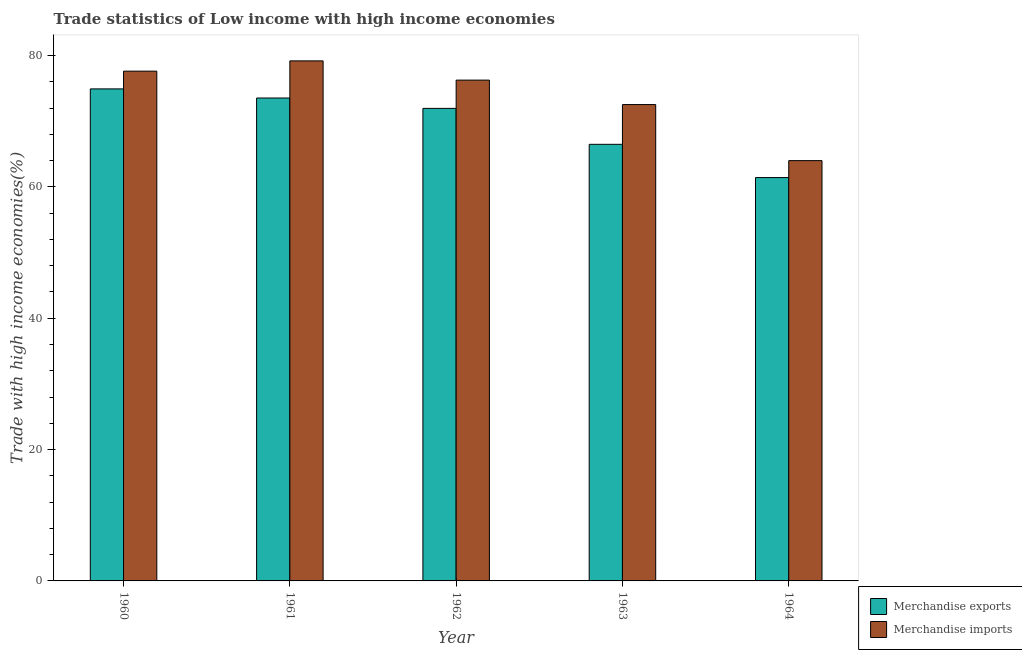How many different coloured bars are there?
Your answer should be very brief. 2. How many bars are there on the 1st tick from the left?
Keep it short and to the point. 2. How many bars are there on the 3rd tick from the right?
Make the answer very short. 2. What is the merchandise exports in 1963?
Offer a terse response. 66.48. Across all years, what is the maximum merchandise imports?
Your response must be concise. 79.18. Across all years, what is the minimum merchandise imports?
Provide a succinct answer. 63.99. In which year was the merchandise imports maximum?
Your answer should be compact. 1961. In which year was the merchandise exports minimum?
Provide a short and direct response. 1964. What is the total merchandise exports in the graph?
Your answer should be very brief. 348.28. What is the difference between the merchandise imports in 1961 and that in 1963?
Give a very brief answer. 6.65. What is the difference between the merchandise imports in 1962 and the merchandise exports in 1964?
Provide a succinct answer. 12.26. What is the average merchandise exports per year?
Offer a terse response. 69.66. In the year 1963, what is the difference between the merchandise imports and merchandise exports?
Your response must be concise. 0. In how many years, is the merchandise imports greater than 52 %?
Make the answer very short. 5. What is the ratio of the merchandise imports in 1960 to that in 1964?
Offer a terse response. 1.21. Is the difference between the merchandise exports in 1960 and 1961 greater than the difference between the merchandise imports in 1960 and 1961?
Offer a very short reply. No. What is the difference between the highest and the second highest merchandise imports?
Offer a very short reply. 1.56. What is the difference between the highest and the lowest merchandise exports?
Your response must be concise. 13.5. Is the sum of the merchandise exports in 1960 and 1962 greater than the maximum merchandise imports across all years?
Make the answer very short. Yes. How many years are there in the graph?
Offer a terse response. 5. Does the graph contain grids?
Your response must be concise. No. How are the legend labels stacked?
Make the answer very short. Vertical. What is the title of the graph?
Your response must be concise. Trade statistics of Low income with high income economies. Does "Health Care" appear as one of the legend labels in the graph?
Make the answer very short. No. What is the label or title of the X-axis?
Keep it short and to the point. Year. What is the label or title of the Y-axis?
Provide a short and direct response. Trade with high income economies(%). What is the Trade with high income economies(%) of Merchandise exports in 1960?
Your response must be concise. 74.91. What is the Trade with high income economies(%) in Merchandise imports in 1960?
Provide a succinct answer. 77.62. What is the Trade with high income economies(%) of Merchandise exports in 1961?
Provide a short and direct response. 73.53. What is the Trade with high income economies(%) in Merchandise imports in 1961?
Make the answer very short. 79.18. What is the Trade with high income economies(%) in Merchandise exports in 1962?
Your response must be concise. 71.95. What is the Trade with high income economies(%) in Merchandise imports in 1962?
Offer a terse response. 76.25. What is the Trade with high income economies(%) of Merchandise exports in 1963?
Offer a very short reply. 66.48. What is the Trade with high income economies(%) of Merchandise imports in 1963?
Your response must be concise. 72.53. What is the Trade with high income economies(%) in Merchandise exports in 1964?
Provide a succinct answer. 61.41. What is the Trade with high income economies(%) in Merchandise imports in 1964?
Ensure brevity in your answer.  63.99. Across all years, what is the maximum Trade with high income economies(%) in Merchandise exports?
Your response must be concise. 74.91. Across all years, what is the maximum Trade with high income economies(%) in Merchandise imports?
Offer a very short reply. 79.18. Across all years, what is the minimum Trade with high income economies(%) in Merchandise exports?
Make the answer very short. 61.41. Across all years, what is the minimum Trade with high income economies(%) of Merchandise imports?
Your answer should be very brief. 63.99. What is the total Trade with high income economies(%) in Merchandise exports in the graph?
Your answer should be compact. 348.28. What is the total Trade with high income economies(%) in Merchandise imports in the graph?
Provide a succinct answer. 369.57. What is the difference between the Trade with high income economies(%) of Merchandise exports in 1960 and that in 1961?
Make the answer very short. 1.39. What is the difference between the Trade with high income economies(%) of Merchandise imports in 1960 and that in 1961?
Your answer should be very brief. -1.56. What is the difference between the Trade with high income economies(%) in Merchandise exports in 1960 and that in 1962?
Your answer should be very brief. 2.97. What is the difference between the Trade with high income economies(%) of Merchandise imports in 1960 and that in 1962?
Make the answer very short. 1.37. What is the difference between the Trade with high income economies(%) in Merchandise exports in 1960 and that in 1963?
Provide a short and direct response. 8.44. What is the difference between the Trade with high income economies(%) of Merchandise imports in 1960 and that in 1963?
Provide a succinct answer. 5.09. What is the difference between the Trade with high income economies(%) of Merchandise exports in 1960 and that in 1964?
Ensure brevity in your answer.  13.5. What is the difference between the Trade with high income economies(%) in Merchandise imports in 1960 and that in 1964?
Provide a short and direct response. 13.62. What is the difference between the Trade with high income economies(%) in Merchandise exports in 1961 and that in 1962?
Offer a very short reply. 1.58. What is the difference between the Trade with high income economies(%) of Merchandise imports in 1961 and that in 1962?
Provide a short and direct response. 2.93. What is the difference between the Trade with high income economies(%) in Merchandise exports in 1961 and that in 1963?
Provide a short and direct response. 7.05. What is the difference between the Trade with high income economies(%) in Merchandise imports in 1961 and that in 1963?
Your answer should be very brief. 6.65. What is the difference between the Trade with high income economies(%) of Merchandise exports in 1961 and that in 1964?
Ensure brevity in your answer.  12.11. What is the difference between the Trade with high income economies(%) in Merchandise imports in 1961 and that in 1964?
Provide a succinct answer. 15.19. What is the difference between the Trade with high income economies(%) of Merchandise exports in 1962 and that in 1963?
Offer a very short reply. 5.47. What is the difference between the Trade with high income economies(%) of Merchandise imports in 1962 and that in 1963?
Your answer should be very brief. 3.72. What is the difference between the Trade with high income economies(%) of Merchandise exports in 1962 and that in 1964?
Keep it short and to the point. 10.54. What is the difference between the Trade with high income economies(%) in Merchandise imports in 1962 and that in 1964?
Provide a succinct answer. 12.26. What is the difference between the Trade with high income economies(%) in Merchandise exports in 1963 and that in 1964?
Ensure brevity in your answer.  5.06. What is the difference between the Trade with high income economies(%) of Merchandise imports in 1963 and that in 1964?
Provide a short and direct response. 8.53. What is the difference between the Trade with high income economies(%) in Merchandise exports in 1960 and the Trade with high income economies(%) in Merchandise imports in 1961?
Make the answer very short. -4.27. What is the difference between the Trade with high income economies(%) in Merchandise exports in 1960 and the Trade with high income economies(%) in Merchandise imports in 1962?
Your answer should be compact. -1.34. What is the difference between the Trade with high income economies(%) of Merchandise exports in 1960 and the Trade with high income economies(%) of Merchandise imports in 1963?
Give a very brief answer. 2.39. What is the difference between the Trade with high income economies(%) of Merchandise exports in 1960 and the Trade with high income economies(%) of Merchandise imports in 1964?
Your answer should be very brief. 10.92. What is the difference between the Trade with high income economies(%) in Merchandise exports in 1961 and the Trade with high income economies(%) in Merchandise imports in 1962?
Your answer should be very brief. -2.72. What is the difference between the Trade with high income economies(%) in Merchandise exports in 1961 and the Trade with high income economies(%) in Merchandise imports in 1964?
Provide a short and direct response. 9.53. What is the difference between the Trade with high income economies(%) in Merchandise exports in 1962 and the Trade with high income economies(%) in Merchandise imports in 1963?
Provide a succinct answer. -0.58. What is the difference between the Trade with high income economies(%) of Merchandise exports in 1962 and the Trade with high income economies(%) of Merchandise imports in 1964?
Provide a succinct answer. 7.96. What is the difference between the Trade with high income economies(%) of Merchandise exports in 1963 and the Trade with high income economies(%) of Merchandise imports in 1964?
Your answer should be very brief. 2.48. What is the average Trade with high income economies(%) in Merchandise exports per year?
Keep it short and to the point. 69.66. What is the average Trade with high income economies(%) in Merchandise imports per year?
Keep it short and to the point. 73.91. In the year 1960, what is the difference between the Trade with high income economies(%) of Merchandise exports and Trade with high income economies(%) of Merchandise imports?
Ensure brevity in your answer.  -2.7. In the year 1961, what is the difference between the Trade with high income economies(%) of Merchandise exports and Trade with high income economies(%) of Merchandise imports?
Offer a terse response. -5.65. In the year 1962, what is the difference between the Trade with high income economies(%) in Merchandise exports and Trade with high income economies(%) in Merchandise imports?
Your answer should be very brief. -4.3. In the year 1963, what is the difference between the Trade with high income economies(%) of Merchandise exports and Trade with high income economies(%) of Merchandise imports?
Give a very brief answer. -6.05. In the year 1964, what is the difference between the Trade with high income economies(%) of Merchandise exports and Trade with high income economies(%) of Merchandise imports?
Provide a succinct answer. -2.58. What is the ratio of the Trade with high income economies(%) of Merchandise exports in 1960 to that in 1961?
Offer a very short reply. 1.02. What is the ratio of the Trade with high income economies(%) of Merchandise imports in 1960 to that in 1961?
Make the answer very short. 0.98. What is the ratio of the Trade with high income economies(%) in Merchandise exports in 1960 to that in 1962?
Provide a short and direct response. 1.04. What is the ratio of the Trade with high income economies(%) of Merchandise imports in 1960 to that in 1962?
Provide a short and direct response. 1.02. What is the ratio of the Trade with high income economies(%) in Merchandise exports in 1960 to that in 1963?
Give a very brief answer. 1.13. What is the ratio of the Trade with high income economies(%) in Merchandise imports in 1960 to that in 1963?
Offer a very short reply. 1.07. What is the ratio of the Trade with high income economies(%) in Merchandise exports in 1960 to that in 1964?
Offer a terse response. 1.22. What is the ratio of the Trade with high income economies(%) of Merchandise imports in 1960 to that in 1964?
Offer a terse response. 1.21. What is the ratio of the Trade with high income economies(%) of Merchandise exports in 1961 to that in 1962?
Provide a short and direct response. 1.02. What is the ratio of the Trade with high income economies(%) of Merchandise imports in 1961 to that in 1962?
Provide a short and direct response. 1.04. What is the ratio of the Trade with high income economies(%) in Merchandise exports in 1961 to that in 1963?
Offer a very short reply. 1.11. What is the ratio of the Trade with high income economies(%) of Merchandise imports in 1961 to that in 1963?
Give a very brief answer. 1.09. What is the ratio of the Trade with high income economies(%) of Merchandise exports in 1961 to that in 1964?
Your answer should be compact. 1.2. What is the ratio of the Trade with high income economies(%) in Merchandise imports in 1961 to that in 1964?
Keep it short and to the point. 1.24. What is the ratio of the Trade with high income economies(%) in Merchandise exports in 1962 to that in 1963?
Your answer should be compact. 1.08. What is the ratio of the Trade with high income economies(%) in Merchandise imports in 1962 to that in 1963?
Keep it short and to the point. 1.05. What is the ratio of the Trade with high income economies(%) of Merchandise exports in 1962 to that in 1964?
Your answer should be compact. 1.17. What is the ratio of the Trade with high income economies(%) of Merchandise imports in 1962 to that in 1964?
Make the answer very short. 1.19. What is the ratio of the Trade with high income economies(%) of Merchandise exports in 1963 to that in 1964?
Your response must be concise. 1.08. What is the ratio of the Trade with high income economies(%) of Merchandise imports in 1963 to that in 1964?
Offer a terse response. 1.13. What is the difference between the highest and the second highest Trade with high income economies(%) of Merchandise exports?
Offer a very short reply. 1.39. What is the difference between the highest and the second highest Trade with high income economies(%) of Merchandise imports?
Your answer should be compact. 1.56. What is the difference between the highest and the lowest Trade with high income economies(%) of Merchandise exports?
Offer a terse response. 13.5. What is the difference between the highest and the lowest Trade with high income economies(%) in Merchandise imports?
Your response must be concise. 15.19. 